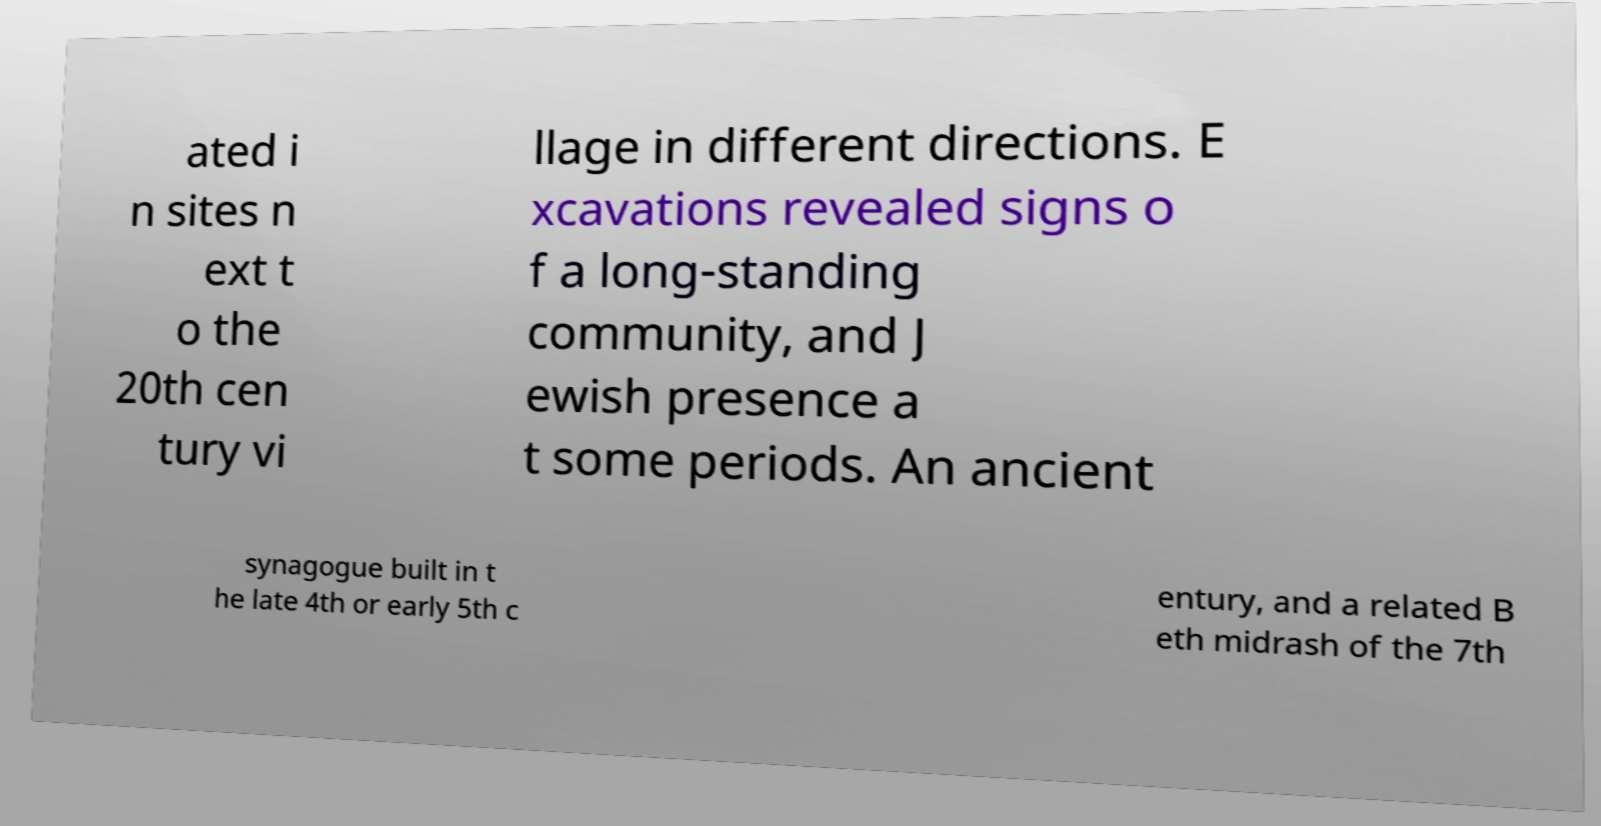There's text embedded in this image that I need extracted. Can you transcribe it verbatim? ated i n sites n ext t o the 20th cen tury vi llage in different directions. E xcavations revealed signs o f a long-standing community, and J ewish presence a t some periods. An ancient synagogue built in t he late 4th or early 5th c entury, and a related B eth midrash of the 7th 